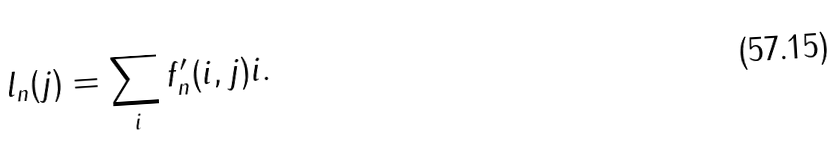<formula> <loc_0><loc_0><loc_500><loc_500>l _ { n } ( j ) = \sum _ { i } f ^ { \prime } _ { n } ( i , j ) i .</formula> 